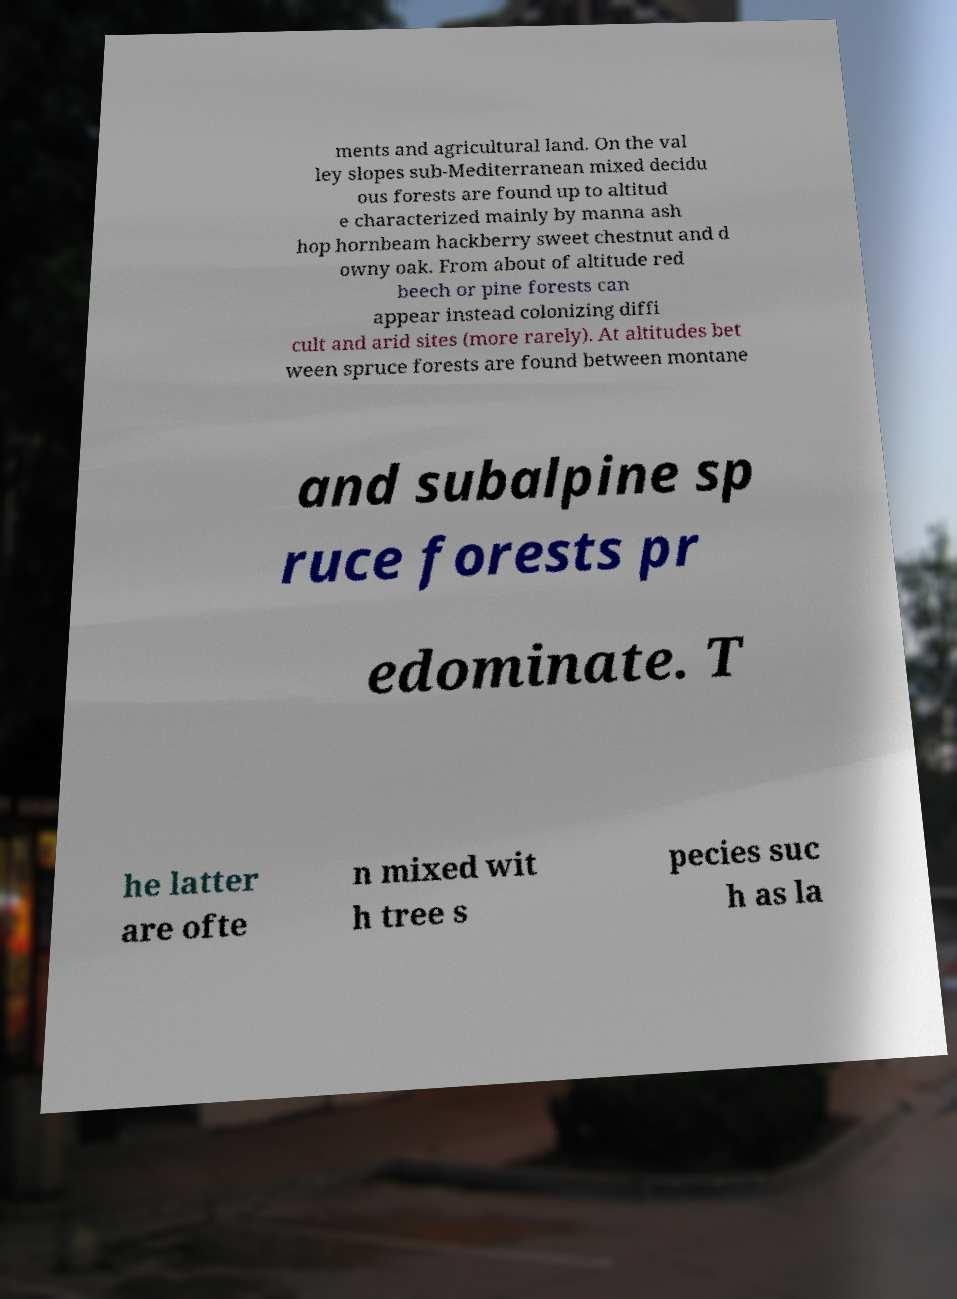Could you assist in decoding the text presented in this image and type it out clearly? ments and agricultural land. On the val ley slopes sub-Mediterranean mixed decidu ous forests are found up to altitud e characterized mainly by manna ash hop hornbeam hackberry sweet chestnut and d owny oak. From about of altitude red beech or pine forests can appear instead colonizing diffi cult and arid sites (more rarely). At altitudes bet ween spruce forests are found between montane and subalpine sp ruce forests pr edominate. T he latter are ofte n mixed wit h tree s pecies suc h as la 